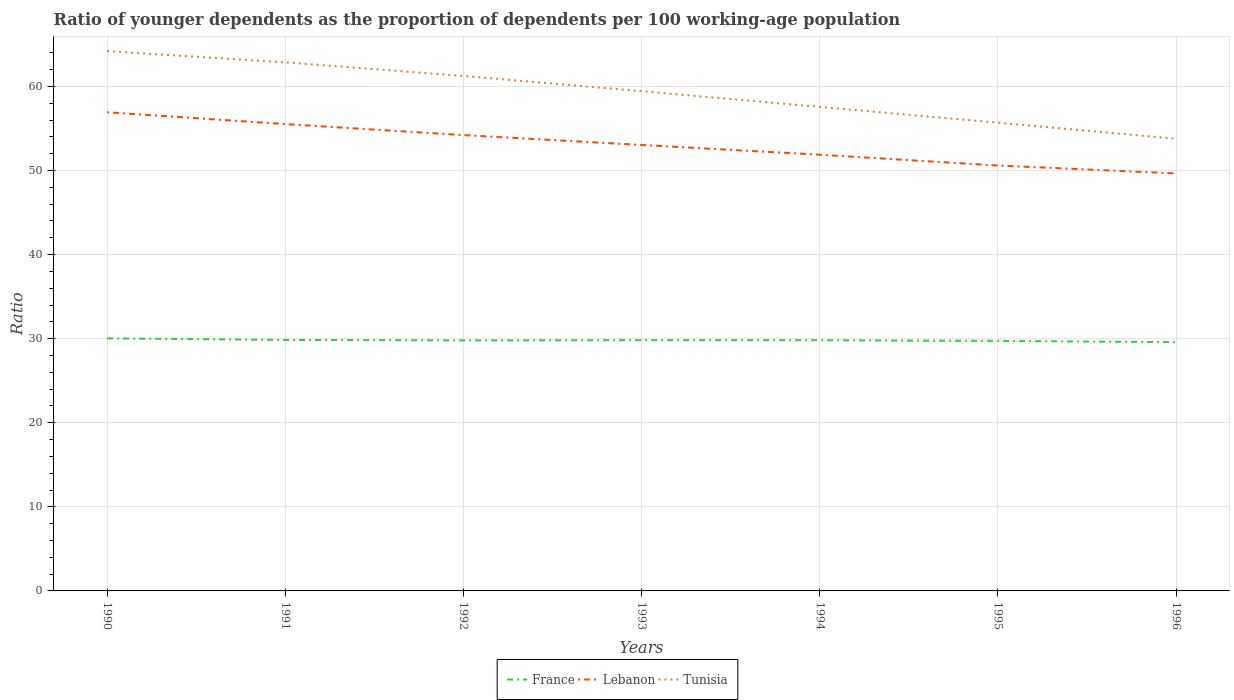How many different coloured lines are there?
Your answer should be very brief. 3. Does the line corresponding to Tunisia intersect with the line corresponding to France?
Make the answer very short. No. Is the number of lines equal to the number of legend labels?
Provide a succinct answer. Yes. Across all years, what is the maximum age dependency ratio(young) in France?
Your response must be concise. 29.58. In which year was the age dependency ratio(young) in France maximum?
Make the answer very short. 1996. What is the total age dependency ratio(young) in France in the graph?
Ensure brevity in your answer.  0.19. What is the difference between the highest and the second highest age dependency ratio(young) in Lebanon?
Offer a very short reply. 7.28. How many lines are there?
Offer a very short reply. 3. Does the graph contain grids?
Offer a terse response. Yes. Where does the legend appear in the graph?
Your answer should be very brief. Bottom center. How many legend labels are there?
Keep it short and to the point. 3. What is the title of the graph?
Provide a succinct answer. Ratio of younger dependents as the proportion of dependents per 100 working-age population. Does "Romania" appear as one of the legend labels in the graph?
Keep it short and to the point. No. What is the label or title of the X-axis?
Provide a short and direct response. Years. What is the label or title of the Y-axis?
Your answer should be very brief. Ratio. What is the Ratio in France in 1990?
Give a very brief answer. 30.04. What is the Ratio of Lebanon in 1990?
Your answer should be very brief. 56.92. What is the Ratio in Tunisia in 1990?
Provide a short and direct response. 64.19. What is the Ratio of France in 1991?
Offer a very short reply. 29.85. What is the Ratio of Lebanon in 1991?
Give a very brief answer. 55.51. What is the Ratio in Tunisia in 1991?
Your answer should be very brief. 62.86. What is the Ratio in France in 1992?
Your answer should be very brief. 29.79. What is the Ratio of Lebanon in 1992?
Provide a short and direct response. 54.21. What is the Ratio of Tunisia in 1992?
Make the answer very short. 61.24. What is the Ratio in France in 1993?
Keep it short and to the point. 29.81. What is the Ratio in Lebanon in 1993?
Your response must be concise. 53.03. What is the Ratio of Tunisia in 1993?
Provide a short and direct response. 59.43. What is the Ratio in France in 1994?
Your answer should be compact. 29.81. What is the Ratio in Lebanon in 1994?
Provide a short and direct response. 51.87. What is the Ratio of Tunisia in 1994?
Provide a short and direct response. 57.56. What is the Ratio of France in 1995?
Provide a short and direct response. 29.73. What is the Ratio in Lebanon in 1995?
Offer a very short reply. 50.59. What is the Ratio in Tunisia in 1995?
Offer a terse response. 55.68. What is the Ratio in France in 1996?
Give a very brief answer. 29.58. What is the Ratio of Lebanon in 1996?
Your answer should be very brief. 49.65. What is the Ratio in Tunisia in 1996?
Provide a succinct answer. 53.77. Across all years, what is the maximum Ratio of France?
Offer a terse response. 30.04. Across all years, what is the maximum Ratio in Lebanon?
Your answer should be compact. 56.92. Across all years, what is the maximum Ratio in Tunisia?
Ensure brevity in your answer.  64.19. Across all years, what is the minimum Ratio of France?
Your response must be concise. 29.58. Across all years, what is the minimum Ratio in Lebanon?
Your answer should be very brief. 49.65. Across all years, what is the minimum Ratio of Tunisia?
Offer a very short reply. 53.77. What is the total Ratio of France in the graph?
Keep it short and to the point. 208.62. What is the total Ratio of Lebanon in the graph?
Give a very brief answer. 371.78. What is the total Ratio in Tunisia in the graph?
Ensure brevity in your answer.  414.74. What is the difference between the Ratio in France in 1990 and that in 1991?
Provide a succinct answer. 0.19. What is the difference between the Ratio of Lebanon in 1990 and that in 1991?
Offer a very short reply. 1.41. What is the difference between the Ratio in Tunisia in 1990 and that in 1991?
Offer a very short reply. 1.34. What is the difference between the Ratio of France in 1990 and that in 1992?
Keep it short and to the point. 0.24. What is the difference between the Ratio of Lebanon in 1990 and that in 1992?
Your answer should be compact. 2.72. What is the difference between the Ratio in Tunisia in 1990 and that in 1992?
Offer a terse response. 2.95. What is the difference between the Ratio of France in 1990 and that in 1993?
Your response must be concise. 0.22. What is the difference between the Ratio of Lebanon in 1990 and that in 1993?
Make the answer very short. 3.89. What is the difference between the Ratio in Tunisia in 1990 and that in 1993?
Your answer should be compact. 4.76. What is the difference between the Ratio of France in 1990 and that in 1994?
Provide a succinct answer. 0.23. What is the difference between the Ratio in Lebanon in 1990 and that in 1994?
Ensure brevity in your answer.  5.05. What is the difference between the Ratio of Tunisia in 1990 and that in 1994?
Your answer should be compact. 6.63. What is the difference between the Ratio of France in 1990 and that in 1995?
Your answer should be compact. 0.3. What is the difference between the Ratio in Lebanon in 1990 and that in 1995?
Your response must be concise. 6.34. What is the difference between the Ratio in Tunisia in 1990 and that in 1995?
Your response must be concise. 8.51. What is the difference between the Ratio of France in 1990 and that in 1996?
Keep it short and to the point. 0.45. What is the difference between the Ratio in Lebanon in 1990 and that in 1996?
Offer a terse response. 7.28. What is the difference between the Ratio of Tunisia in 1990 and that in 1996?
Provide a succinct answer. 10.42. What is the difference between the Ratio of France in 1991 and that in 1992?
Keep it short and to the point. 0.06. What is the difference between the Ratio in Lebanon in 1991 and that in 1992?
Your answer should be compact. 1.31. What is the difference between the Ratio of Tunisia in 1991 and that in 1992?
Offer a terse response. 1.62. What is the difference between the Ratio of France in 1991 and that in 1993?
Provide a short and direct response. 0.03. What is the difference between the Ratio in Lebanon in 1991 and that in 1993?
Offer a very short reply. 2.48. What is the difference between the Ratio of Tunisia in 1991 and that in 1993?
Your answer should be compact. 3.42. What is the difference between the Ratio in France in 1991 and that in 1994?
Make the answer very short. 0.04. What is the difference between the Ratio of Lebanon in 1991 and that in 1994?
Your response must be concise. 3.64. What is the difference between the Ratio of Tunisia in 1991 and that in 1994?
Make the answer very short. 5.3. What is the difference between the Ratio of France in 1991 and that in 1995?
Offer a very short reply. 0.11. What is the difference between the Ratio of Lebanon in 1991 and that in 1995?
Ensure brevity in your answer.  4.93. What is the difference between the Ratio of Tunisia in 1991 and that in 1995?
Keep it short and to the point. 7.18. What is the difference between the Ratio of France in 1991 and that in 1996?
Your response must be concise. 0.26. What is the difference between the Ratio in Lebanon in 1991 and that in 1996?
Offer a very short reply. 5.87. What is the difference between the Ratio of Tunisia in 1991 and that in 1996?
Your response must be concise. 9.09. What is the difference between the Ratio of France in 1992 and that in 1993?
Provide a short and direct response. -0.02. What is the difference between the Ratio of Lebanon in 1992 and that in 1993?
Provide a succinct answer. 1.17. What is the difference between the Ratio in Tunisia in 1992 and that in 1993?
Your answer should be compact. 1.81. What is the difference between the Ratio of France in 1992 and that in 1994?
Provide a succinct answer. -0.02. What is the difference between the Ratio of Lebanon in 1992 and that in 1994?
Your answer should be very brief. 2.33. What is the difference between the Ratio in Tunisia in 1992 and that in 1994?
Your response must be concise. 3.68. What is the difference between the Ratio of France in 1992 and that in 1995?
Make the answer very short. 0.06. What is the difference between the Ratio of Lebanon in 1992 and that in 1995?
Your answer should be compact. 3.62. What is the difference between the Ratio of Tunisia in 1992 and that in 1995?
Ensure brevity in your answer.  5.56. What is the difference between the Ratio of France in 1992 and that in 1996?
Keep it short and to the point. 0.21. What is the difference between the Ratio of Lebanon in 1992 and that in 1996?
Offer a very short reply. 4.56. What is the difference between the Ratio in Tunisia in 1992 and that in 1996?
Your response must be concise. 7.47. What is the difference between the Ratio of France in 1993 and that in 1994?
Your answer should be compact. 0. What is the difference between the Ratio in Lebanon in 1993 and that in 1994?
Provide a succinct answer. 1.16. What is the difference between the Ratio of Tunisia in 1993 and that in 1994?
Provide a short and direct response. 1.87. What is the difference between the Ratio in France in 1993 and that in 1995?
Offer a very short reply. 0.08. What is the difference between the Ratio in Lebanon in 1993 and that in 1995?
Offer a very short reply. 2.44. What is the difference between the Ratio in Tunisia in 1993 and that in 1995?
Provide a succinct answer. 3.75. What is the difference between the Ratio of France in 1993 and that in 1996?
Your answer should be compact. 0.23. What is the difference between the Ratio in Lebanon in 1993 and that in 1996?
Keep it short and to the point. 3.38. What is the difference between the Ratio of Tunisia in 1993 and that in 1996?
Give a very brief answer. 5.66. What is the difference between the Ratio of France in 1994 and that in 1995?
Your answer should be compact. 0.08. What is the difference between the Ratio in Lebanon in 1994 and that in 1995?
Provide a succinct answer. 1.28. What is the difference between the Ratio in Tunisia in 1994 and that in 1995?
Offer a terse response. 1.88. What is the difference between the Ratio of France in 1994 and that in 1996?
Offer a very short reply. 0.23. What is the difference between the Ratio of Lebanon in 1994 and that in 1996?
Your answer should be compact. 2.22. What is the difference between the Ratio of Tunisia in 1994 and that in 1996?
Your answer should be very brief. 3.79. What is the difference between the Ratio in France in 1995 and that in 1996?
Give a very brief answer. 0.15. What is the difference between the Ratio in Lebanon in 1995 and that in 1996?
Your answer should be compact. 0.94. What is the difference between the Ratio in Tunisia in 1995 and that in 1996?
Your response must be concise. 1.91. What is the difference between the Ratio of France in 1990 and the Ratio of Lebanon in 1991?
Keep it short and to the point. -25.48. What is the difference between the Ratio of France in 1990 and the Ratio of Tunisia in 1991?
Your answer should be compact. -32.82. What is the difference between the Ratio in Lebanon in 1990 and the Ratio in Tunisia in 1991?
Provide a short and direct response. -5.93. What is the difference between the Ratio of France in 1990 and the Ratio of Lebanon in 1992?
Your answer should be very brief. -24.17. What is the difference between the Ratio of France in 1990 and the Ratio of Tunisia in 1992?
Your response must be concise. -31.2. What is the difference between the Ratio of Lebanon in 1990 and the Ratio of Tunisia in 1992?
Provide a succinct answer. -4.32. What is the difference between the Ratio in France in 1990 and the Ratio in Lebanon in 1993?
Provide a succinct answer. -23. What is the difference between the Ratio in France in 1990 and the Ratio in Tunisia in 1993?
Offer a very short reply. -29.4. What is the difference between the Ratio in Lebanon in 1990 and the Ratio in Tunisia in 1993?
Give a very brief answer. -2.51. What is the difference between the Ratio in France in 1990 and the Ratio in Lebanon in 1994?
Ensure brevity in your answer.  -21.84. What is the difference between the Ratio of France in 1990 and the Ratio of Tunisia in 1994?
Offer a terse response. -27.52. What is the difference between the Ratio in Lebanon in 1990 and the Ratio in Tunisia in 1994?
Give a very brief answer. -0.64. What is the difference between the Ratio of France in 1990 and the Ratio of Lebanon in 1995?
Offer a very short reply. -20.55. What is the difference between the Ratio in France in 1990 and the Ratio in Tunisia in 1995?
Your response must be concise. -25.65. What is the difference between the Ratio of Lebanon in 1990 and the Ratio of Tunisia in 1995?
Your response must be concise. 1.24. What is the difference between the Ratio in France in 1990 and the Ratio in Lebanon in 1996?
Offer a terse response. -19.61. What is the difference between the Ratio in France in 1990 and the Ratio in Tunisia in 1996?
Your response must be concise. -23.73. What is the difference between the Ratio of Lebanon in 1990 and the Ratio of Tunisia in 1996?
Offer a terse response. 3.15. What is the difference between the Ratio of France in 1991 and the Ratio of Lebanon in 1992?
Offer a very short reply. -24.36. What is the difference between the Ratio of France in 1991 and the Ratio of Tunisia in 1992?
Offer a very short reply. -31.39. What is the difference between the Ratio of Lebanon in 1991 and the Ratio of Tunisia in 1992?
Offer a terse response. -5.73. What is the difference between the Ratio in France in 1991 and the Ratio in Lebanon in 1993?
Provide a succinct answer. -23.18. What is the difference between the Ratio in France in 1991 and the Ratio in Tunisia in 1993?
Provide a short and direct response. -29.59. What is the difference between the Ratio in Lebanon in 1991 and the Ratio in Tunisia in 1993?
Offer a terse response. -3.92. What is the difference between the Ratio in France in 1991 and the Ratio in Lebanon in 1994?
Make the answer very short. -22.02. What is the difference between the Ratio of France in 1991 and the Ratio of Tunisia in 1994?
Offer a very short reply. -27.71. What is the difference between the Ratio in Lebanon in 1991 and the Ratio in Tunisia in 1994?
Offer a terse response. -2.05. What is the difference between the Ratio in France in 1991 and the Ratio in Lebanon in 1995?
Give a very brief answer. -20.74. What is the difference between the Ratio of France in 1991 and the Ratio of Tunisia in 1995?
Ensure brevity in your answer.  -25.84. What is the difference between the Ratio in Lebanon in 1991 and the Ratio in Tunisia in 1995?
Ensure brevity in your answer.  -0.17. What is the difference between the Ratio of France in 1991 and the Ratio of Lebanon in 1996?
Your answer should be compact. -19.8. What is the difference between the Ratio of France in 1991 and the Ratio of Tunisia in 1996?
Your response must be concise. -23.92. What is the difference between the Ratio of Lebanon in 1991 and the Ratio of Tunisia in 1996?
Make the answer very short. 1.74. What is the difference between the Ratio in France in 1992 and the Ratio in Lebanon in 1993?
Offer a very short reply. -23.24. What is the difference between the Ratio in France in 1992 and the Ratio in Tunisia in 1993?
Offer a terse response. -29.64. What is the difference between the Ratio of Lebanon in 1992 and the Ratio of Tunisia in 1993?
Provide a succinct answer. -5.23. What is the difference between the Ratio in France in 1992 and the Ratio in Lebanon in 1994?
Offer a very short reply. -22.08. What is the difference between the Ratio of France in 1992 and the Ratio of Tunisia in 1994?
Make the answer very short. -27.77. What is the difference between the Ratio of Lebanon in 1992 and the Ratio of Tunisia in 1994?
Offer a very short reply. -3.35. What is the difference between the Ratio in France in 1992 and the Ratio in Lebanon in 1995?
Your answer should be very brief. -20.8. What is the difference between the Ratio in France in 1992 and the Ratio in Tunisia in 1995?
Your answer should be very brief. -25.89. What is the difference between the Ratio of Lebanon in 1992 and the Ratio of Tunisia in 1995?
Provide a succinct answer. -1.48. What is the difference between the Ratio of France in 1992 and the Ratio of Lebanon in 1996?
Ensure brevity in your answer.  -19.86. What is the difference between the Ratio in France in 1992 and the Ratio in Tunisia in 1996?
Your answer should be very brief. -23.98. What is the difference between the Ratio of Lebanon in 1992 and the Ratio of Tunisia in 1996?
Your response must be concise. 0.44. What is the difference between the Ratio in France in 1993 and the Ratio in Lebanon in 1994?
Your answer should be compact. -22.06. What is the difference between the Ratio in France in 1993 and the Ratio in Tunisia in 1994?
Ensure brevity in your answer.  -27.75. What is the difference between the Ratio of Lebanon in 1993 and the Ratio of Tunisia in 1994?
Offer a very short reply. -4.53. What is the difference between the Ratio of France in 1993 and the Ratio of Lebanon in 1995?
Your answer should be compact. -20.77. What is the difference between the Ratio in France in 1993 and the Ratio in Tunisia in 1995?
Ensure brevity in your answer.  -25.87. What is the difference between the Ratio of Lebanon in 1993 and the Ratio of Tunisia in 1995?
Provide a short and direct response. -2.65. What is the difference between the Ratio in France in 1993 and the Ratio in Lebanon in 1996?
Keep it short and to the point. -19.83. What is the difference between the Ratio of France in 1993 and the Ratio of Tunisia in 1996?
Keep it short and to the point. -23.96. What is the difference between the Ratio of Lebanon in 1993 and the Ratio of Tunisia in 1996?
Offer a terse response. -0.74. What is the difference between the Ratio in France in 1994 and the Ratio in Lebanon in 1995?
Keep it short and to the point. -20.78. What is the difference between the Ratio in France in 1994 and the Ratio in Tunisia in 1995?
Offer a terse response. -25.87. What is the difference between the Ratio of Lebanon in 1994 and the Ratio of Tunisia in 1995?
Ensure brevity in your answer.  -3.81. What is the difference between the Ratio of France in 1994 and the Ratio of Lebanon in 1996?
Offer a terse response. -19.84. What is the difference between the Ratio in France in 1994 and the Ratio in Tunisia in 1996?
Provide a succinct answer. -23.96. What is the difference between the Ratio of Lebanon in 1994 and the Ratio of Tunisia in 1996?
Provide a succinct answer. -1.9. What is the difference between the Ratio of France in 1995 and the Ratio of Lebanon in 1996?
Your response must be concise. -19.91. What is the difference between the Ratio in France in 1995 and the Ratio in Tunisia in 1996?
Provide a succinct answer. -24.04. What is the difference between the Ratio in Lebanon in 1995 and the Ratio in Tunisia in 1996?
Keep it short and to the point. -3.18. What is the average Ratio of France per year?
Provide a succinct answer. 29.8. What is the average Ratio of Lebanon per year?
Offer a very short reply. 53.11. What is the average Ratio of Tunisia per year?
Make the answer very short. 59.25. In the year 1990, what is the difference between the Ratio in France and Ratio in Lebanon?
Your response must be concise. -26.89. In the year 1990, what is the difference between the Ratio of France and Ratio of Tunisia?
Keep it short and to the point. -34.16. In the year 1990, what is the difference between the Ratio of Lebanon and Ratio of Tunisia?
Your answer should be compact. -7.27. In the year 1991, what is the difference between the Ratio in France and Ratio in Lebanon?
Provide a succinct answer. -25.67. In the year 1991, what is the difference between the Ratio in France and Ratio in Tunisia?
Your answer should be very brief. -33.01. In the year 1991, what is the difference between the Ratio in Lebanon and Ratio in Tunisia?
Offer a terse response. -7.34. In the year 1992, what is the difference between the Ratio of France and Ratio of Lebanon?
Ensure brevity in your answer.  -24.41. In the year 1992, what is the difference between the Ratio in France and Ratio in Tunisia?
Provide a short and direct response. -31.45. In the year 1992, what is the difference between the Ratio in Lebanon and Ratio in Tunisia?
Your response must be concise. -7.03. In the year 1993, what is the difference between the Ratio of France and Ratio of Lebanon?
Offer a very short reply. -23.22. In the year 1993, what is the difference between the Ratio of France and Ratio of Tunisia?
Keep it short and to the point. -29.62. In the year 1993, what is the difference between the Ratio of Lebanon and Ratio of Tunisia?
Your answer should be compact. -6.4. In the year 1994, what is the difference between the Ratio in France and Ratio in Lebanon?
Your answer should be very brief. -22.06. In the year 1994, what is the difference between the Ratio in France and Ratio in Tunisia?
Offer a terse response. -27.75. In the year 1994, what is the difference between the Ratio in Lebanon and Ratio in Tunisia?
Ensure brevity in your answer.  -5.69. In the year 1995, what is the difference between the Ratio in France and Ratio in Lebanon?
Your answer should be compact. -20.85. In the year 1995, what is the difference between the Ratio in France and Ratio in Tunisia?
Make the answer very short. -25.95. In the year 1995, what is the difference between the Ratio of Lebanon and Ratio of Tunisia?
Your answer should be compact. -5.09. In the year 1996, what is the difference between the Ratio in France and Ratio in Lebanon?
Give a very brief answer. -20.06. In the year 1996, what is the difference between the Ratio in France and Ratio in Tunisia?
Provide a short and direct response. -24.19. In the year 1996, what is the difference between the Ratio in Lebanon and Ratio in Tunisia?
Your answer should be compact. -4.12. What is the ratio of the Ratio of France in 1990 to that in 1991?
Your response must be concise. 1.01. What is the ratio of the Ratio of Lebanon in 1990 to that in 1991?
Provide a short and direct response. 1.03. What is the ratio of the Ratio of Tunisia in 1990 to that in 1991?
Offer a terse response. 1.02. What is the ratio of the Ratio in France in 1990 to that in 1992?
Your answer should be compact. 1.01. What is the ratio of the Ratio of Lebanon in 1990 to that in 1992?
Keep it short and to the point. 1.05. What is the ratio of the Ratio of Tunisia in 1990 to that in 1992?
Ensure brevity in your answer.  1.05. What is the ratio of the Ratio of France in 1990 to that in 1993?
Keep it short and to the point. 1.01. What is the ratio of the Ratio in Lebanon in 1990 to that in 1993?
Your response must be concise. 1.07. What is the ratio of the Ratio of Tunisia in 1990 to that in 1993?
Provide a short and direct response. 1.08. What is the ratio of the Ratio in France in 1990 to that in 1994?
Give a very brief answer. 1.01. What is the ratio of the Ratio of Lebanon in 1990 to that in 1994?
Make the answer very short. 1.1. What is the ratio of the Ratio in Tunisia in 1990 to that in 1994?
Your answer should be very brief. 1.12. What is the ratio of the Ratio of Lebanon in 1990 to that in 1995?
Provide a short and direct response. 1.13. What is the ratio of the Ratio of Tunisia in 1990 to that in 1995?
Make the answer very short. 1.15. What is the ratio of the Ratio in France in 1990 to that in 1996?
Provide a succinct answer. 1.02. What is the ratio of the Ratio in Lebanon in 1990 to that in 1996?
Ensure brevity in your answer.  1.15. What is the ratio of the Ratio in Tunisia in 1990 to that in 1996?
Your answer should be compact. 1.19. What is the ratio of the Ratio of France in 1991 to that in 1992?
Your answer should be very brief. 1. What is the ratio of the Ratio of Lebanon in 1991 to that in 1992?
Your answer should be very brief. 1.02. What is the ratio of the Ratio of Tunisia in 1991 to that in 1992?
Your answer should be very brief. 1.03. What is the ratio of the Ratio of Lebanon in 1991 to that in 1993?
Make the answer very short. 1.05. What is the ratio of the Ratio in Tunisia in 1991 to that in 1993?
Your answer should be compact. 1.06. What is the ratio of the Ratio in France in 1991 to that in 1994?
Keep it short and to the point. 1. What is the ratio of the Ratio in Lebanon in 1991 to that in 1994?
Provide a short and direct response. 1.07. What is the ratio of the Ratio of Tunisia in 1991 to that in 1994?
Provide a succinct answer. 1.09. What is the ratio of the Ratio of Lebanon in 1991 to that in 1995?
Provide a succinct answer. 1.1. What is the ratio of the Ratio in Tunisia in 1991 to that in 1995?
Provide a short and direct response. 1.13. What is the ratio of the Ratio in France in 1991 to that in 1996?
Your answer should be compact. 1.01. What is the ratio of the Ratio in Lebanon in 1991 to that in 1996?
Offer a terse response. 1.12. What is the ratio of the Ratio of Tunisia in 1991 to that in 1996?
Make the answer very short. 1.17. What is the ratio of the Ratio of Lebanon in 1992 to that in 1993?
Your answer should be very brief. 1.02. What is the ratio of the Ratio in Tunisia in 1992 to that in 1993?
Ensure brevity in your answer.  1.03. What is the ratio of the Ratio in France in 1992 to that in 1994?
Give a very brief answer. 1. What is the ratio of the Ratio in Lebanon in 1992 to that in 1994?
Offer a very short reply. 1.04. What is the ratio of the Ratio in Tunisia in 1992 to that in 1994?
Ensure brevity in your answer.  1.06. What is the ratio of the Ratio in France in 1992 to that in 1995?
Ensure brevity in your answer.  1. What is the ratio of the Ratio of Lebanon in 1992 to that in 1995?
Provide a short and direct response. 1.07. What is the ratio of the Ratio in Tunisia in 1992 to that in 1995?
Provide a succinct answer. 1.1. What is the ratio of the Ratio of Lebanon in 1992 to that in 1996?
Ensure brevity in your answer.  1.09. What is the ratio of the Ratio of Tunisia in 1992 to that in 1996?
Ensure brevity in your answer.  1.14. What is the ratio of the Ratio of France in 1993 to that in 1994?
Give a very brief answer. 1. What is the ratio of the Ratio in Lebanon in 1993 to that in 1994?
Your response must be concise. 1.02. What is the ratio of the Ratio of Tunisia in 1993 to that in 1994?
Your response must be concise. 1.03. What is the ratio of the Ratio in Lebanon in 1993 to that in 1995?
Offer a very short reply. 1.05. What is the ratio of the Ratio of Tunisia in 1993 to that in 1995?
Give a very brief answer. 1.07. What is the ratio of the Ratio of France in 1993 to that in 1996?
Give a very brief answer. 1.01. What is the ratio of the Ratio in Lebanon in 1993 to that in 1996?
Provide a short and direct response. 1.07. What is the ratio of the Ratio of Tunisia in 1993 to that in 1996?
Your response must be concise. 1.11. What is the ratio of the Ratio of France in 1994 to that in 1995?
Your answer should be compact. 1. What is the ratio of the Ratio in Lebanon in 1994 to that in 1995?
Offer a very short reply. 1.03. What is the ratio of the Ratio of Tunisia in 1994 to that in 1995?
Make the answer very short. 1.03. What is the ratio of the Ratio of France in 1994 to that in 1996?
Your response must be concise. 1.01. What is the ratio of the Ratio of Lebanon in 1994 to that in 1996?
Provide a succinct answer. 1.04. What is the ratio of the Ratio in Tunisia in 1994 to that in 1996?
Your answer should be very brief. 1.07. What is the ratio of the Ratio of France in 1995 to that in 1996?
Your response must be concise. 1.01. What is the ratio of the Ratio of Lebanon in 1995 to that in 1996?
Make the answer very short. 1.02. What is the ratio of the Ratio in Tunisia in 1995 to that in 1996?
Your response must be concise. 1.04. What is the difference between the highest and the second highest Ratio in France?
Keep it short and to the point. 0.19. What is the difference between the highest and the second highest Ratio in Lebanon?
Provide a short and direct response. 1.41. What is the difference between the highest and the second highest Ratio in Tunisia?
Your answer should be very brief. 1.34. What is the difference between the highest and the lowest Ratio of France?
Your answer should be compact. 0.45. What is the difference between the highest and the lowest Ratio in Lebanon?
Your response must be concise. 7.28. What is the difference between the highest and the lowest Ratio of Tunisia?
Keep it short and to the point. 10.42. 